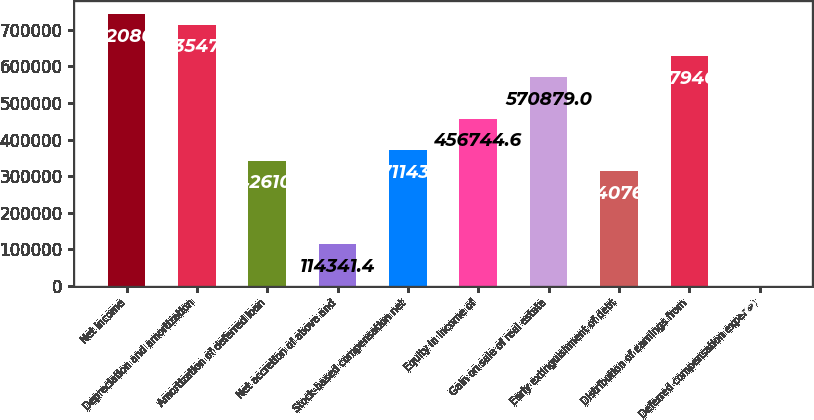Convert chart to OTSL. <chart><loc_0><loc_0><loc_500><loc_500><bar_chart><fcel>Net income<fcel>Depreciation and amortization<fcel>Amortization of deferred loan<fcel>Net accretion of above and<fcel>Stock-based compensation net<fcel>Equity in income of<fcel>Gain on sale of real estate<fcel>Early extinguishment of debt<fcel>Distribution of earnings from<fcel>Deferred compensation expense<nl><fcel>742081<fcel>713547<fcel>342610<fcel>114341<fcel>371144<fcel>456745<fcel>570879<fcel>314077<fcel>627946<fcel>207<nl></chart> 